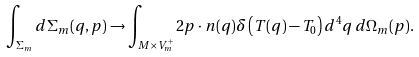Convert formula to latex. <formula><loc_0><loc_0><loc_500><loc_500>\int _ { \Sigma _ { m } } d \Sigma _ { m } ( q , p ) \rightarrow \int _ { M \times V _ { m } ^ { + } } 2 p \cdot n ( q ) \delta \left ( T ( q ) - T _ { 0 } \right ) d ^ { 4 } q \, d \Omega _ { m } ( p ) .</formula> 